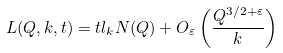Convert formula to latex. <formula><loc_0><loc_0><loc_500><loc_500>L ( Q , k , t ) = t l _ { k } N ( Q ) + O _ { \varepsilon } \left ( \frac { Q ^ { 3 / 2 + \varepsilon } } { k } \right )</formula> 